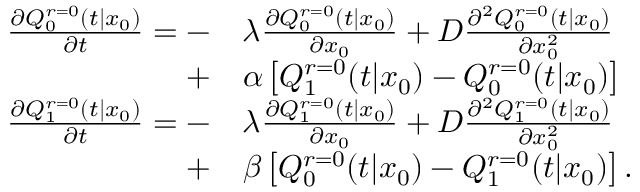<formula> <loc_0><loc_0><loc_500><loc_500>\begin{array} { r l } { \frac { \partial Q _ { 0 } ^ { r = 0 } ( t | x _ { 0 } ) } { \partial t } = - } & { \lambda \frac { \partial Q _ { 0 } ^ { r = 0 } ( t | x _ { 0 } ) } { \partial x _ { 0 } } + D \frac { \partial ^ { 2 } Q _ { 0 } ^ { r = 0 } ( t | x _ { 0 } ) } { \partial x _ { 0 } ^ { 2 } } } \\ { + } & { \alpha \left [ Q _ { 1 } ^ { r = 0 } ( t | x _ { 0 } ) - Q _ { 0 } ^ { r = 0 } ( t | x _ { 0 } ) \right ] } \\ { \frac { \partial Q _ { 1 } ^ { r = 0 } ( t | x _ { 0 } ) } { \partial t } = - } & { \lambda \frac { \partial Q _ { 1 } ^ { r = 0 } ( t | x _ { 0 } ) } { \partial x _ { 0 } } + D \frac { \partial ^ { 2 } Q _ { 1 } ^ { r = 0 } ( t | x _ { 0 } ) } { \partial x _ { 0 } ^ { 2 } } } \\ { + } & { \beta \left [ Q _ { 0 } ^ { r = 0 } ( t | x _ { 0 } ) - Q _ { 1 } ^ { r = 0 } ( t | x _ { 0 } ) \right ] . } \end{array}</formula> 